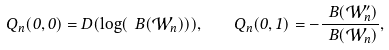<formula> <loc_0><loc_0><loc_500><loc_500>Q _ { n } ( 0 , 0 ) = D ( \log ( \ B ( \mathcal { W } _ { n } ) ) ) , \quad Q _ { n } ( 0 , 1 ) = - \frac { \ B ( \mathcal { W } _ { n } ^ { \prime } ) } { \ B ( \mathcal { W } _ { n } ) } ,</formula> 